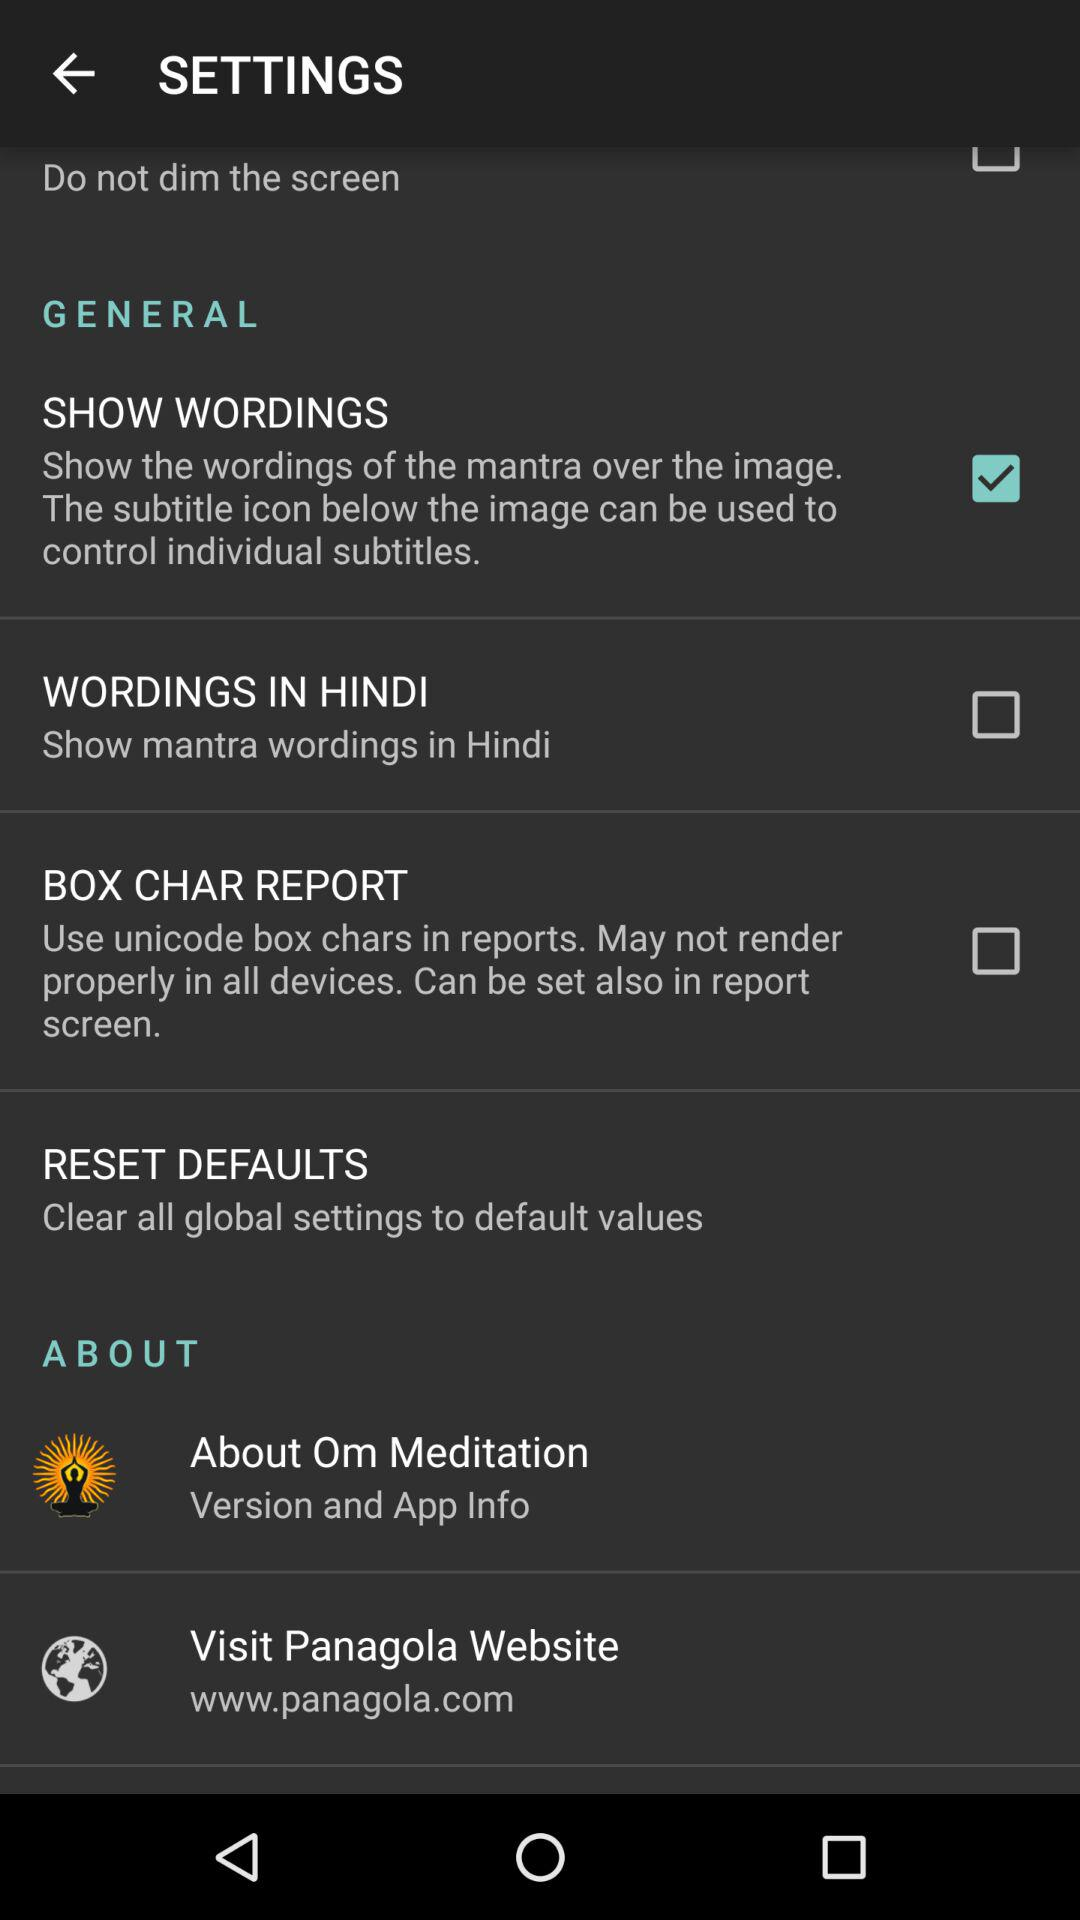What is the status of "SHOW WORDINGS"? The status is "on". 